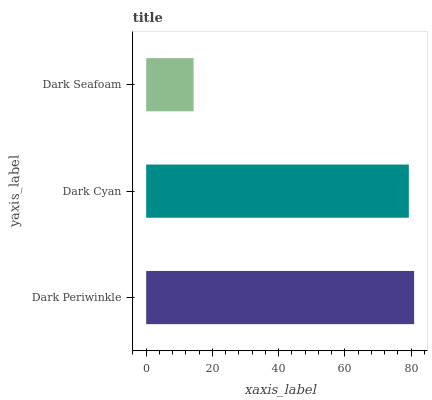Is Dark Seafoam the minimum?
Answer yes or no. Yes. Is Dark Periwinkle the maximum?
Answer yes or no. Yes. Is Dark Cyan the minimum?
Answer yes or no. No. Is Dark Cyan the maximum?
Answer yes or no. No. Is Dark Periwinkle greater than Dark Cyan?
Answer yes or no. Yes. Is Dark Cyan less than Dark Periwinkle?
Answer yes or no. Yes. Is Dark Cyan greater than Dark Periwinkle?
Answer yes or no. No. Is Dark Periwinkle less than Dark Cyan?
Answer yes or no. No. Is Dark Cyan the high median?
Answer yes or no. Yes. Is Dark Cyan the low median?
Answer yes or no. Yes. Is Dark Periwinkle the high median?
Answer yes or no. No. Is Dark Periwinkle the low median?
Answer yes or no. No. 